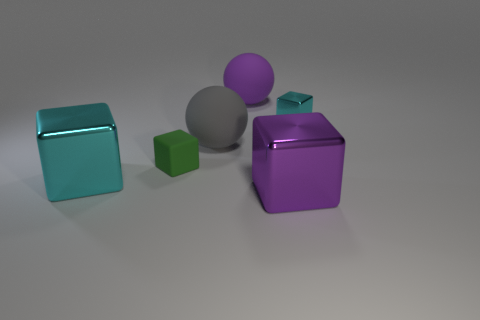Add 1 cyan metal spheres. How many objects exist? 7 Subtract all spheres. How many objects are left? 4 Subtract 0 yellow blocks. How many objects are left? 6 Subtract all purple matte objects. Subtract all purple metal blocks. How many objects are left? 4 Add 2 large gray rubber things. How many large gray rubber things are left? 3 Add 3 big cubes. How many big cubes exist? 5 